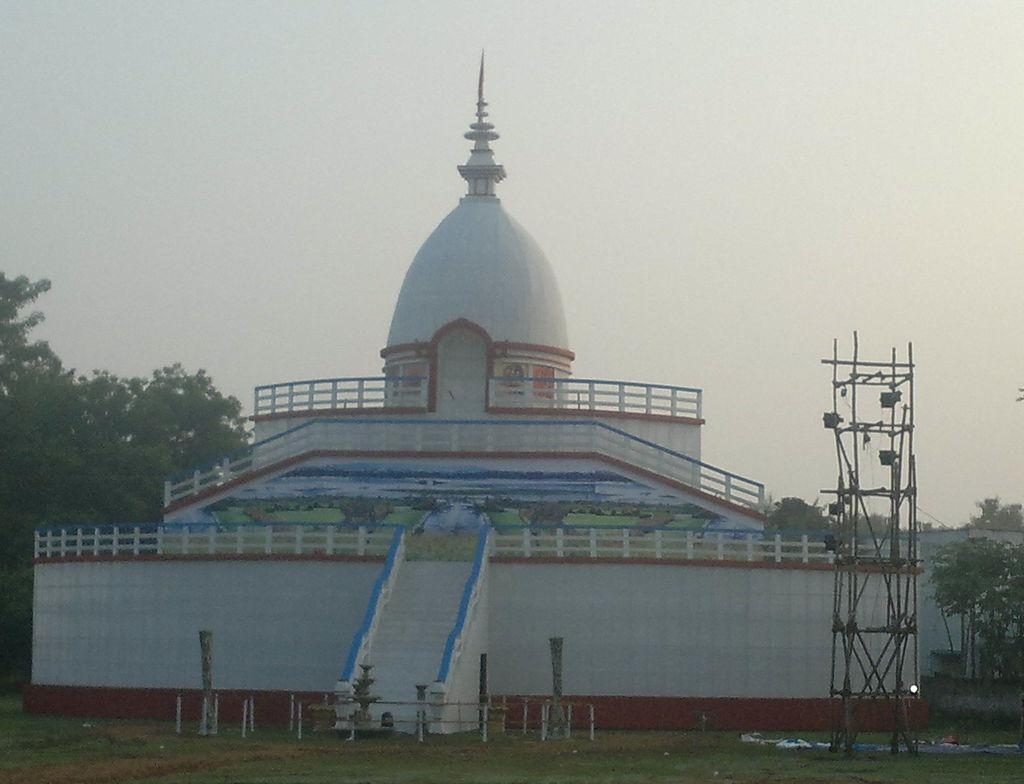What type of structure is in the image? There is a white building in the image. What is located above the building? There is a tomb above the building. What can be seen behind the building? Trees are visible behind the building. What is visible above the building and trees? The sky is visible above the building and trees. How many friends are playing with the spade in the image? There is no spade or friends present in the image. What type of division can be seen in the image? There is no division present in the image; it features a white building, a tomb, trees, and the sky. 